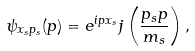Convert formula to latex. <formula><loc_0><loc_0><loc_500><loc_500>\psi _ { x _ { s } p _ { s } } ( p ) = e ^ { i p x _ { s } } j \left ( \frac { p _ { s } p } { m _ { s } } \right ) ,</formula> 